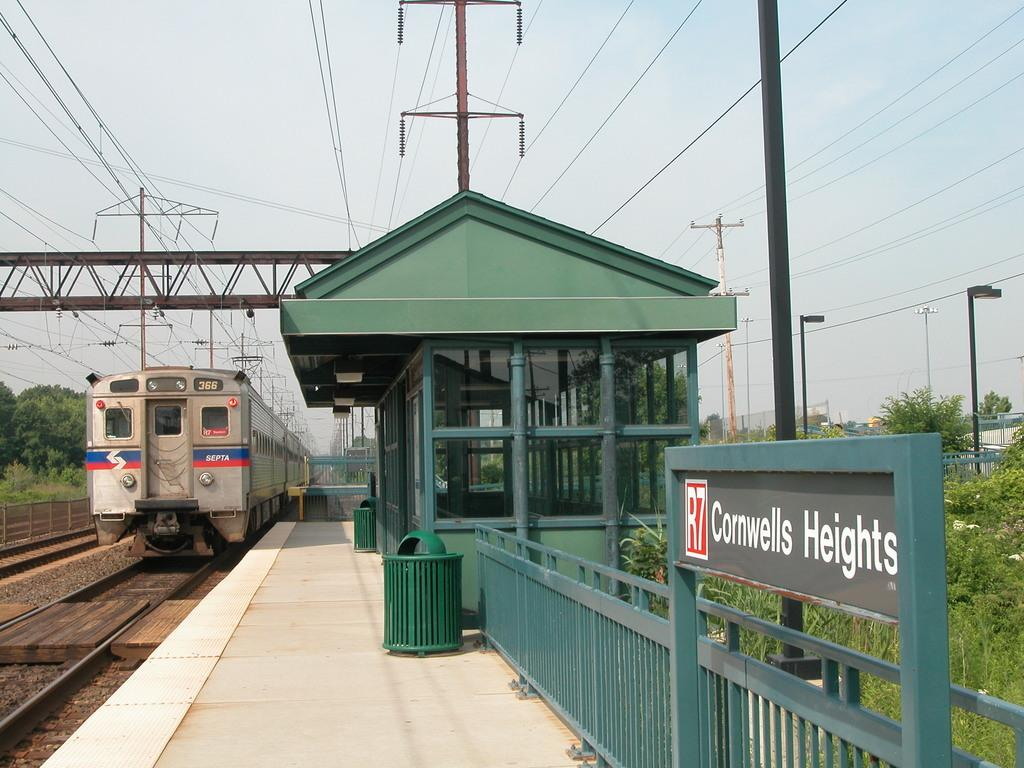What is the main subject of the image? The main subject of the image is a train on the track. What other structures or objects can be seen in the image? There is a shed, a board, a fence, bins, plants, poles, and trees in the image. What is visible in the background of the image? The sky is visible in the background of the image. What authority figure can be seen making a discovery in the image? There is no authority figure or discovery present in the image. What is the image trying to draw attention to? The image does not appear to be trying to draw attention to any specific subject or object; it simply depicts a train on the track and various surrounding structures and objects. 